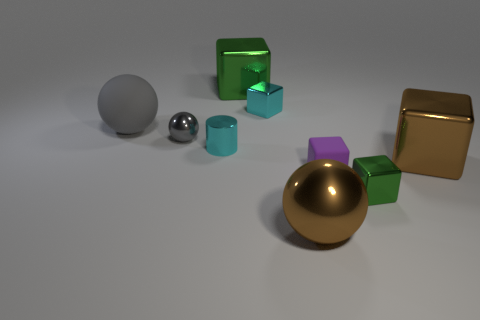What shape is the cyan metal object that is behind the tiny gray metallic ball?
Your response must be concise. Cube. Is the material of the tiny purple object the same as the cyan thing on the left side of the cyan metal cube?
Provide a short and direct response. No. Are any small purple matte blocks visible?
Keep it short and to the point. Yes. Are there any big brown objects left of the small cyan shiny object that is in front of the small cyan shiny thing that is behind the tiny shiny sphere?
Offer a terse response. No. How many big things are either gray rubber things or metallic blocks?
Provide a short and direct response. 3. What color is the matte block that is the same size as the metallic cylinder?
Your response must be concise. Purple. There is a matte ball; how many rubber balls are in front of it?
Your answer should be very brief. 0. Are there any other cylinders made of the same material as the cyan cylinder?
Ensure brevity in your answer.  No. The small thing that is the same color as the shiny cylinder is what shape?
Provide a short and direct response. Cube. There is a big shiny thing that is in front of the small green shiny object; what color is it?
Make the answer very short. Brown. 